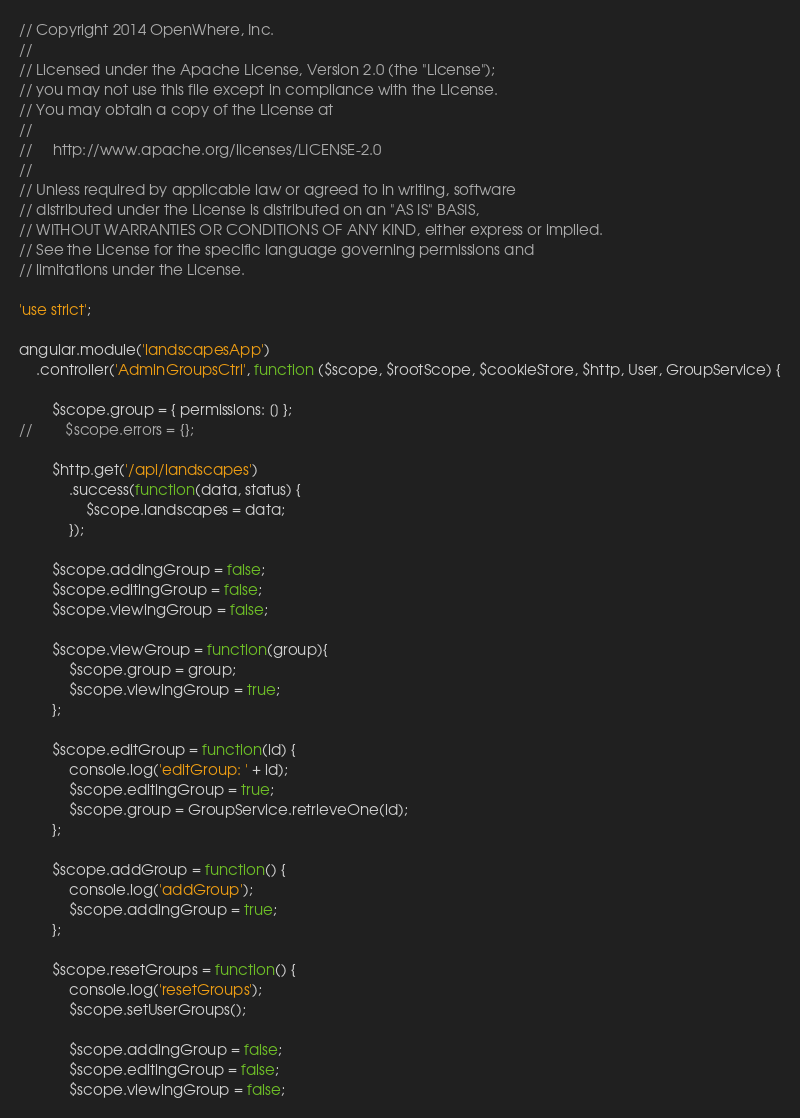<code> <loc_0><loc_0><loc_500><loc_500><_JavaScript_>// Copyright 2014 OpenWhere, Inc.
//
// Licensed under the Apache License, Version 2.0 (the "License");
// you may not use this file except in compliance with the License.
// You may obtain a copy of the License at
//
//     http://www.apache.org/licenses/LICENSE-2.0
//
// Unless required by applicable law or agreed to in writing, software
// distributed under the License is distributed on an "AS IS" BASIS,
// WITHOUT WARRANTIES OR CONDITIONS OF ANY KIND, either express or implied.
// See the License for the specific language governing permissions and
// limitations under the License.

'use strict';

angular.module('landscapesApp')
    .controller('AdminGroupsCtrl', function ($scope, $rootScope, $cookieStore, $http, User, GroupService) {

        $scope.group = { permissions: [] };
//        $scope.errors = {};

        $http.get('/api/landscapes')
            .success(function(data, status) {
                $scope.landscapes = data;
            });

        $scope.addingGroup = false;
        $scope.editingGroup = false;
        $scope.viewingGroup = false;

        $scope.viewGroup = function(group){
            $scope.group = group;
            $scope.viewingGroup = true;
        };

        $scope.editGroup = function(id) {
            console.log('editGroup: ' + id);
            $scope.editingGroup = true;
            $scope.group = GroupService.retrieveOne(id);
        };

        $scope.addGroup = function() {
            console.log('addGroup');
            $scope.addingGroup = true;
        };

        $scope.resetGroups = function() {
            console.log('resetGroups');
            $scope.setUserGroups();

            $scope.addingGroup = false;
            $scope.editingGroup = false;
            $scope.viewingGroup = false;</code> 